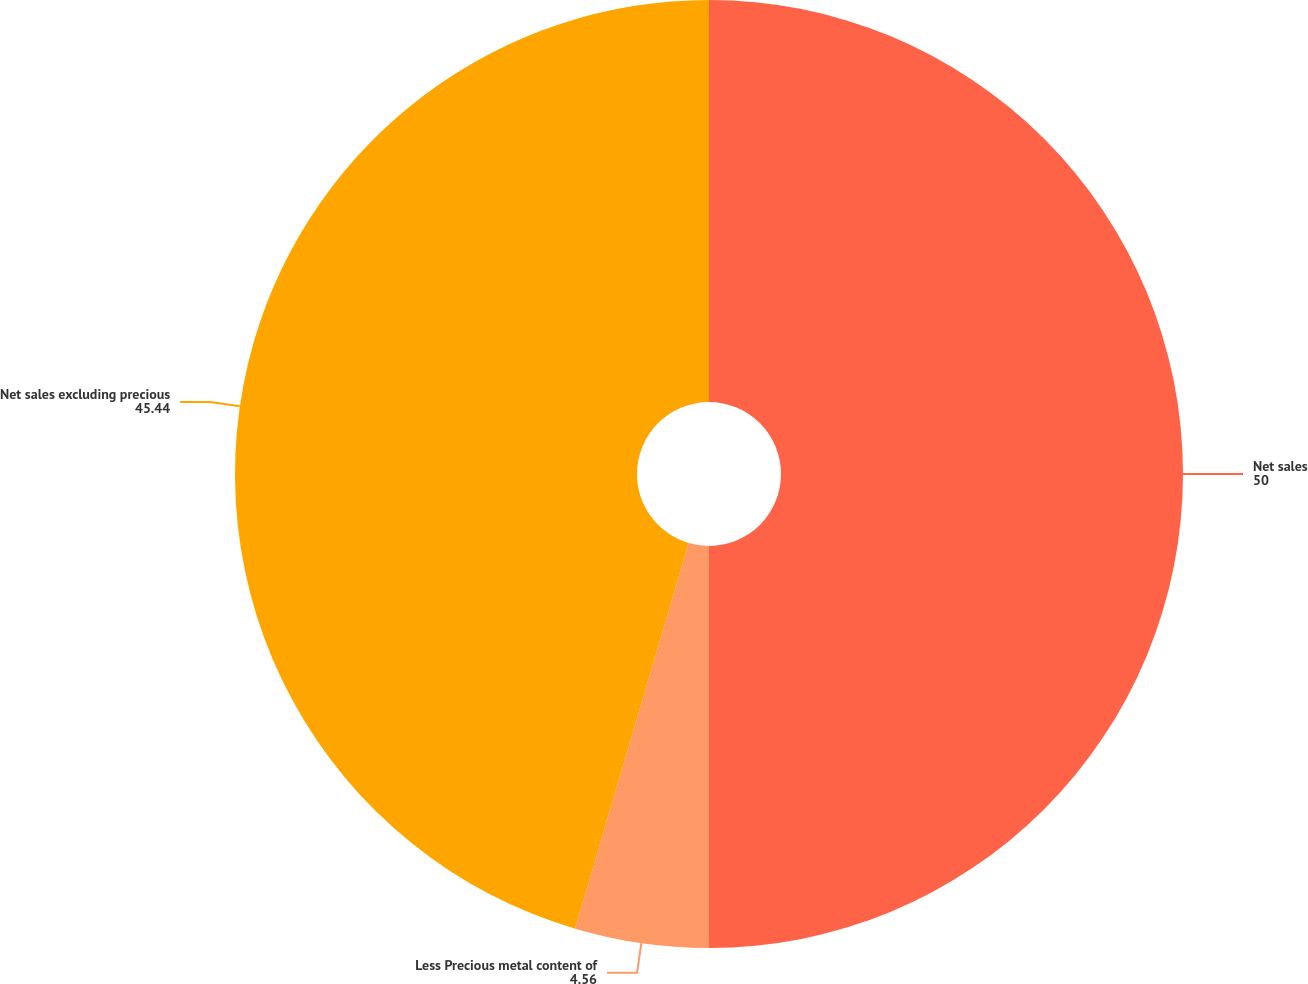Convert chart. <chart><loc_0><loc_0><loc_500><loc_500><pie_chart><fcel>Net sales<fcel>Less Precious metal content of<fcel>Net sales excluding precious<nl><fcel>50.0%<fcel>4.56%<fcel>45.44%<nl></chart> 